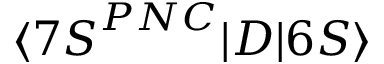<formula> <loc_0><loc_0><loc_500><loc_500>\langle { 7 S } ^ { P N C } | D | 6 S \rangle</formula> 